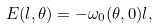<formula> <loc_0><loc_0><loc_500><loc_500>E ( l , \theta ) = - \omega _ { 0 } ( \theta , 0 ) l ,</formula> 